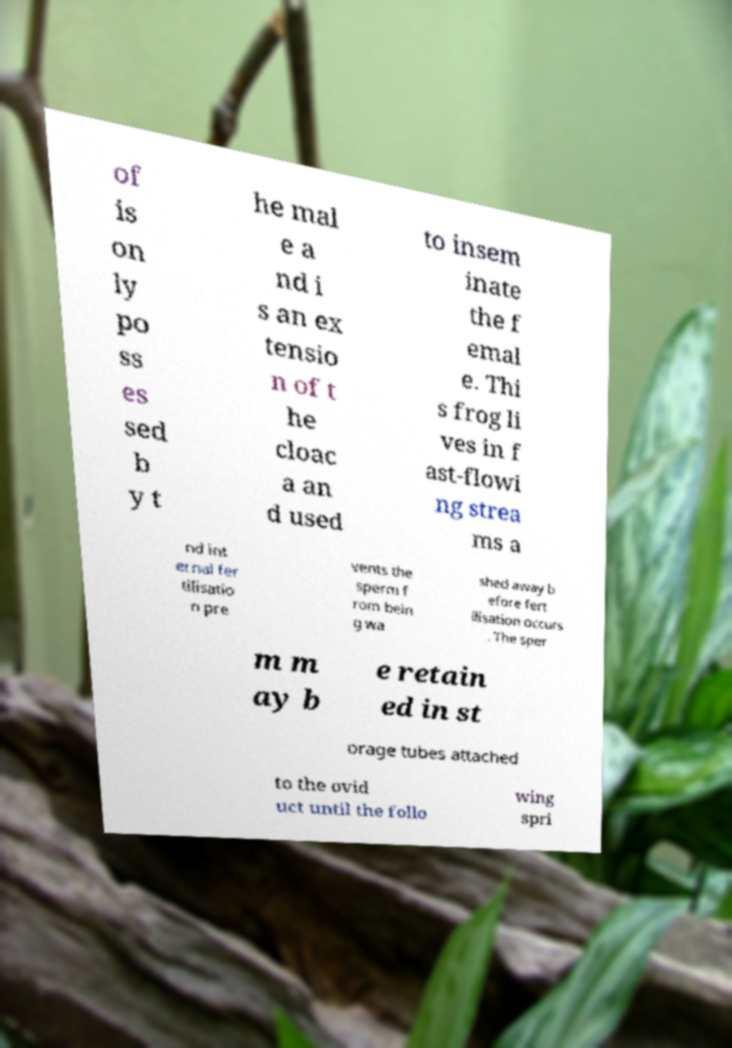What messages or text are displayed in this image? I need them in a readable, typed format. of is on ly po ss es sed b y t he mal e a nd i s an ex tensio n of t he cloac a an d used to insem inate the f emal e. Thi s frog li ves in f ast-flowi ng strea ms a nd int ernal fer tilisatio n pre vents the sperm f rom bein g wa shed away b efore fert ilisation occurs . The sper m m ay b e retain ed in st orage tubes attached to the ovid uct until the follo wing spri 